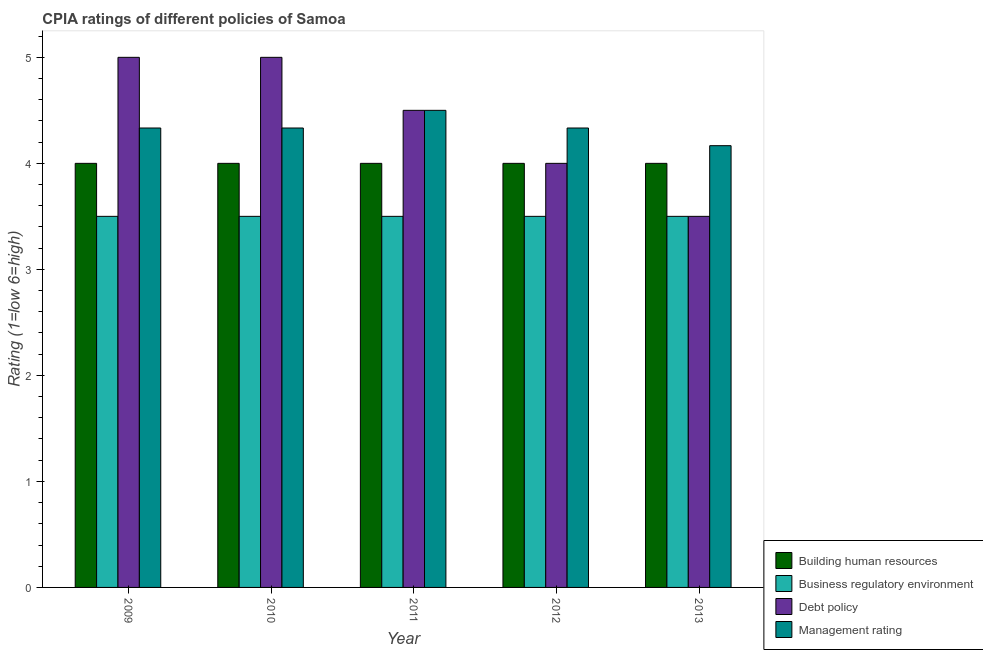How many different coloured bars are there?
Offer a very short reply. 4. Are the number of bars on each tick of the X-axis equal?
Provide a short and direct response. Yes. How many bars are there on the 4th tick from the left?
Your answer should be compact. 4. How many bars are there on the 5th tick from the right?
Provide a short and direct response. 4. What is the label of the 5th group of bars from the left?
Give a very brief answer. 2013. In how many cases, is the number of bars for a given year not equal to the number of legend labels?
Your answer should be very brief. 0. Across all years, what is the minimum cpia rating of business regulatory environment?
Keep it short and to the point. 3.5. What is the average cpia rating of building human resources per year?
Offer a very short reply. 4. In the year 2009, what is the difference between the cpia rating of building human resources and cpia rating of debt policy?
Ensure brevity in your answer.  0. What is the ratio of the cpia rating of debt policy in 2009 to that in 2012?
Provide a succinct answer. 1.25. Is the cpia rating of management in 2010 less than that in 2013?
Keep it short and to the point. No. Is the difference between the cpia rating of management in 2009 and 2013 greater than the difference between the cpia rating of business regulatory environment in 2009 and 2013?
Provide a short and direct response. No. What is the difference between the highest and the second highest cpia rating of management?
Your answer should be very brief. 0.17. What is the difference between the highest and the lowest cpia rating of debt policy?
Ensure brevity in your answer.  1.5. What does the 3rd bar from the left in 2012 represents?
Provide a short and direct response. Debt policy. What does the 4th bar from the right in 2011 represents?
Make the answer very short. Building human resources. Are all the bars in the graph horizontal?
Give a very brief answer. No. What is the difference between two consecutive major ticks on the Y-axis?
Give a very brief answer. 1. Does the graph contain any zero values?
Your answer should be very brief. No. Does the graph contain grids?
Make the answer very short. No. How are the legend labels stacked?
Provide a succinct answer. Vertical. What is the title of the graph?
Ensure brevity in your answer.  CPIA ratings of different policies of Samoa. Does "Korea" appear as one of the legend labels in the graph?
Offer a terse response. No. What is the label or title of the X-axis?
Make the answer very short. Year. What is the Rating (1=low 6=high) in Debt policy in 2009?
Provide a short and direct response. 5. What is the Rating (1=low 6=high) in Management rating in 2009?
Ensure brevity in your answer.  4.33. What is the Rating (1=low 6=high) in Building human resources in 2010?
Provide a succinct answer. 4. What is the Rating (1=low 6=high) of Management rating in 2010?
Provide a succinct answer. 4.33. What is the Rating (1=low 6=high) in Building human resources in 2011?
Your response must be concise. 4. What is the Rating (1=low 6=high) in Business regulatory environment in 2011?
Provide a succinct answer. 3.5. What is the Rating (1=low 6=high) in Debt policy in 2011?
Provide a succinct answer. 4.5. What is the Rating (1=low 6=high) in Business regulatory environment in 2012?
Your answer should be very brief. 3.5. What is the Rating (1=low 6=high) in Management rating in 2012?
Your answer should be compact. 4.33. What is the Rating (1=low 6=high) of Debt policy in 2013?
Offer a very short reply. 3.5. What is the Rating (1=low 6=high) in Management rating in 2013?
Offer a terse response. 4.17. Across all years, what is the maximum Rating (1=low 6=high) in Business regulatory environment?
Ensure brevity in your answer.  3.5. Across all years, what is the minimum Rating (1=low 6=high) in Debt policy?
Your answer should be very brief. 3.5. Across all years, what is the minimum Rating (1=low 6=high) in Management rating?
Offer a very short reply. 4.17. What is the total Rating (1=low 6=high) of Business regulatory environment in the graph?
Your answer should be very brief. 17.5. What is the total Rating (1=low 6=high) of Management rating in the graph?
Your answer should be very brief. 21.67. What is the difference between the Rating (1=low 6=high) of Debt policy in 2009 and that in 2010?
Your answer should be compact. 0. What is the difference between the Rating (1=low 6=high) of Management rating in 2009 and that in 2010?
Provide a succinct answer. 0. What is the difference between the Rating (1=low 6=high) in Business regulatory environment in 2009 and that in 2011?
Your response must be concise. 0. What is the difference between the Rating (1=low 6=high) in Debt policy in 2009 and that in 2011?
Make the answer very short. 0.5. What is the difference between the Rating (1=low 6=high) of Management rating in 2009 and that in 2011?
Keep it short and to the point. -0.17. What is the difference between the Rating (1=low 6=high) in Debt policy in 2009 and that in 2012?
Provide a short and direct response. 1. What is the difference between the Rating (1=low 6=high) in Management rating in 2009 and that in 2012?
Provide a succinct answer. 0. What is the difference between the Rating (1=low 6=high) of Building human resources in 2009 and that in 2013?
Ensure brevity in your answer.  0. What is the difference between the Rating (1=low 6=high) of Building human resources in 2010 and that in 2011?
Your response must be concise. 0. What is the difference between the Rating (1=low 6=high) in Business regulatory environment in 2010 and that in 2011?
Ensure brevity in your answer.  0. What is the difference between the Rating (1=low 6=high) in Management rating in 2010 and that in 2011?
Offer a terse response. -0.17. What is the difference between the Rating (1=low 6=high) in Business regulatory environment in 2010 and that in 2012?
Your response must be concise. 0. What is the difference between the Rating (1=low 6=high) in Debt policy in 2010 and that in 2012?
Provide a succinct answer. 1. What is the difference between the Rating (1=low 6=high) of Management rating in 2010 and that in 2012?
Your response must be concise. 0. What is the difference between the Rating (1=low 6=high) of Debt policy in 2010 and that in 2013?
Make the answer very short. 1.5. What is the difference between the Rating (1=low 6=high) of Debt policy in 2011 and that in 2012?
Your response must be concise. 0.5. What is the difference between the Rating (1=low 6=high) of Management rating in 2011 and that in 2012?
Provide a succinct answer. 0.17. What is the difference between the Rating (1=low 6=high) of Building human resources in 2011 and that in 2013?
Your response must be concise. 0. What is the difference between the Rating (1=low 6=high) of Debt policy in 2011 and that in 2013?
Provide a short and direct response. 1. What is the difference between the Rating (1=low 6=high) in Building human resources in 2012 and that in 2013?
Offer a terse response. 0. What is the difference between the Rating (1=low 6=high) of Business regulatory environment in 2012 and that in 2013?
Ensure brevity in your answer.  0. What is the difference between the Rating (1=low 6=high) of Debt policy in 2012 and that in 2013?
Your answer should be very brief. 0.5. What is the difference between the Rating (1=low 6=high) in Building human resources in 2009 and the Rating (1=low 6=high) in Debt policy in 2010?
Your answer should be very brief. -1. What is the difference between the Rating (1=low 6=high) of Building human resources in 2009 and the Rating (1=low 6=high) of Management rating in 2010?
Provide a short and direct response. -0.33. What is the difference between the Rating (1=low 6=high) of Business regulatory environment in 2009 and the Rating (1=low 6=high) of Debt policy in 2010?
Provide a succinct answer. -1.5. What is the difference between the Rating (1=low 6=high) in Business regulatory environment in 2009 and the Rating (1=low 6=high) in Management rating in 2010?
Give a very brief answer. -0.83. What is the difference between the Rating (1=low 6=high) in Debt policy in 2009 and the Rating (1=low 6=high) in Management rating in 2010?
Ensure brevity in your answer.  0.67. What is the difference between the Rating (1=low 6=high) of Building human resources in 2009 and the Rating (1=low 6=high) of Business regulatory environment in 2011?
Make the answer very short. 0.5. What is the difference between the Rating (1=low 6=high) in Building human resources in 2009 and the Rating (1=low 6=high) in Debt policy in 2011?
Offer a terse response. -0.5. What is the difference between the Rating (1=low 6=high) in Business regulatory environment in 2009 and the Rating (1=low 6=high) in Debt policy in 2011?
Your response must be concise. -1. What is the difference between the Rating (1=low 6=high) of Debt policy in 2009 and the Rating (1=low 6=high) of Management rating in 2011?
Make the answer very short. 0.5. What is the difference between the Rating (1=low 6=high) of Building human resources in 2009 and the Rating (1=low 6=high) of Debt policy in 2012?
Your answer should be compact. 0. What is the difference between the Rating (1=low 6=high) of Business regulatory environment in 2009 and the Rating (1=low 6=high) of Debt policy in 2012?
Ensure brevity in your answer.  -0.5. What is the difference between the Rating (1=low 6=high) of Business regulatory environment in 2009 and the Rating (1=low 6=high) of Management rating in 2012?
Offer a very short reply. -0.83. What is the difference between the Rating (1=low 6=high) in Debt policy in 2009 and the Rating (1=low 6=high) in Management rating in 2012?
Give a very brief answer. 0.67. What is the difference between the Rating (1=low 6=high) of Building human resources in 2009 and the Rating (1=low 6=high) of Business regulatory environment in 2013?
Provide a succinct answer. 0.5. What is the difference between the Rating (1=low 6=high) of Building human resources in 2009 and the Rating (1=low 6=high) of Debt policy in 2013?
Give a very brief answer. 0.5. What is the difference between the Rating (1=low 6=high) of Building human resources in 2009 and the Rating (1=low 6=high) of Management rating in 2013?
Keep it short and to the point. -0.17. What is the difference between the Rating (1=low 6=high) of Debt policy in 2009 and the Rating (1=low 6=high) of Management rating in 2013?
Offer a terse response. 0.83. What is the difference between the Rating (1=low 6=high) of Building human resources in 2010 and the Rating (1=low 6=high) of Business regulatory environment in 2011?
Ensure brevity in your answer.  0.5. What is the difference between the Rating (1=low 6=high) in Building human resources in 2010 and the Rating (1=low 6=high) in Debt policy in 2011?
Provide a short and direct response. -0.5. What is the difference between the Rating (1=low 6=high) of Building human resources in 2010 and the Rating (1=low 6=high) of Management rating in 2011?
Your response must be concise. -0.5. What is the difference between the Rating (1=low 6=high) in Business regulatory environment in 2010 and the Rating (1=low 6=high) in Debt policy in 2011?
Offer a very short reply. -1. What is the difference between the Rating (1=low 6=high) of Business regulatory environment in 2010 and the Rating (1=low 6=high) of Management rating in 2011?
Your response must be concise. -1. What is the difference between the Rating (1=low 6=high) in Business regulatory environment in 2010 and the Rating (1=low 6=high) in Debt policy in 2012?
Make the answer very short. -0.5. What is the difference between the Rating (1=low 6=high) in Debt policy in 2010 and the Rating (1=low 6=high) in Management rating in 2012?
Offer a very short reply. 0.67. What is the difference between the Rating (1=low 6=high) of Building human resources in 2010 and the Rating (1=low 6=high) of Business regulatory environment in 2013?
Keep it short and to the point. 0.5. What is the difference between the Rating (1=low 6=high) of Building human resources in 2010 and the Rating (1=low 6=high) of Management rating in 2013?
Provide a succinct answer. -0.17. What is the difference between the Rating (1=low 6=high) in Building human resources in 2011 and the Rating (1=low 6=high) in Debt policy in 2012?
Give a very brief answer. 0. What is the difference between the Rating (1=low 6=high) of Business regulatory environment in 2011 and the Rating (1=low 6=high) of Debt policy in 2012?
Give a very brief answer. -0.5. What is the difference between the Rating (1=low 6=high) of Business regulatory environment in 2011 and the Rating (1=low 6=high) of Management rating in 2012?
Ensure brevity in your answer.  -0.83. What is the difference between the Rating (1=low 6=high) in Building human resources in 2011 and the Rating (1=low 6=high) in Debt policy in 2013?
Your answer should be compact. 0.5. What is the difference between the Rating (1=low 6=high) in Building human resources in 2011 and the Rating (1=low 6=high) in Management rating in 2013?
Provide a short and direct response. -0.17. What is the difference between the Rating (1=low 6=high) of Business regulatory environment in 2011 and the Rating (1=low 6=high) of Debt policy in 2013?
Provide a short and direct response. 0. What is the difference between the Rating (1=low 6=high) of Building human resources in 2012 and the Rating (1=low 6=high) of Business regulatory environment in 2013?
Keep it short and to the point. 0.5. What is the difference between the Rating (1=low 6=high) in Building human resources in 2012 and the Rating (1=low 6=high) in Management rating in 2013?
Your answer should be compact. -0.17. What is the difference between the Rating (1=low 6=high) in Business regulatory environment in 2012 and the Rating (1=low 6=high) in Debt policy in 2013?
Make the answer very short. 0. What is the average Rating (1=low 6=high) in Debt policy per year?
Offer a very short reply. 4.4. What is the average Rating (1=low 6=high) in Management rating per year?
Your response must be concise. 4.33. In the year 2010, what is the difference between the Rating (1=low 6=high) in Building human resources and Rating (1=low 6=high) in Management rating?
Offer a very short reply. -0.33. In the year 2010, what is the difference between the Rating (1=low 6=high) of Business regulatory environment and Rating (1=low 6=high) of Management rating?
Provide a short and direct response. -0.83. In the year 2011, what is the difference between the Rating (1=low 6=high) in Building human resources and Rating (1=low 6=high) in Business regulatory environment?
Your answer should be compact. 0.5. In the year 2011, what is the difference between the Rating (1=low 6=high) of Building human resources and Rating (1=low 6=high) of Debt policy?
Offer a very short reply. -0.5. In the year 2011, what is the difference between the Rating (1=low 6=high) in Building human resources and Rating (1=low 6=high) in Management rating?
Provide a succinct answer. -0.5. In the year 2011, what is the difference between the Rating (1=low 6=high) in Business regulatory environment and Rating (1=low 6=high) in Management rating?
Make the answer very short. -1. In the year 2012, what is the difference between the Rating (1=low 6=high) of Building human resources and Rating (1=low 6=high) of Debt policy?
Provide a succinct answer. 0. In the year 2012, what is the difference between the Rating (1=low 6=high) in Building human resources and Rating (1=low 6=high) in Management rating?
Ensure brevity in your answer.  -0.33. In the year 2012, what is the difference between the Rating (1=low 6=high) in Business regulatory environment and Rating (1=low 6=high) in Debt policy?
Offer a very short reply. -0.5. In the year 2012, what is the difference between the Rating (1=low 6=high) in Business regulatory environment and Rating (1=low 6=high) in Management rating?
Offer a very short reply. -0.83. In the year 2013, what is the difference between the Rating (1=low 6=high) in Building human resources and Rating (1=low 6=high) in Debt policy?
Make the answer very short. 0.5. In the year 2013, what is the difference between the Rating (1=low 6=high) in Building human resources and Rating (1=low 6=high) in Management rating?
Ensure brevity in your answer.  -0.17. In the year 2013, what is the difference between the Rating (1=low 6=high) in Business regulatory environment and Rating (1=low 6=high) in Debt policy?
Provide a succinct answer. 0. What is the ratio of the Rating (1=low 6=high) in Building human resources in 2009 to that in 2011?
Ensure brevity in your answer.  1. What is the ratio of the Rating (1=low 6=high) of Business regulatory environment in 2009 to that in 2011?
Offer a terse response. 1. What is the ratio of the Rating (1=low 6=high) in Debt policy in 2009 to that in 2011?
Give a very brief answer. 1.11. What is the ratio of the Rating (1=low 6=high) in Building human resources in 2009 to that in 2012?
Give a very brief answer. 1. What is the ratio of the Rating (1=low 6=high) of Business regulatory environment in 2009 to that in 2012?
Your answer should be compact. 1. What is the ratio of the Rating (1=low 6=high) in Building human resources in 2009 to that in 2013?
Your response must be concise. 1. What is the ratio of the Rating (1=low 6=high) of Debt policy in 2009 to that in 2013?
Offer a very short reply. 1.43. What is the ratio of the Rating (1=low 6=high) in Management rating in 2010 to that in 2011?
Keep it short and to the point. 0.96. What is the ratio of the Rating (1=low 6=high) in Building human resources in 2010 to that in 2012?
Ensure brevity in your answer.  1. What is the ratio of the Rating (1=low 6=high) in Business regulatory environment in 2010 to that in 2012?
Your answer should be compact. 1. What is the ratio of the Rating (1=low 6=high) of Management rating in 2010 to that in 2012?
Provide a succinct answer. 1. What is the ratio of the Rating (1=low 6=high) of Debt policy in 2010 to that in 2013?
Your answer should be compact. 1.43. What is the ratio of the Rating (1=low 6=high) of Management rating in 2010 to that in 2013?
Keep it short and to the point. 1.04. What is the ratio of the Rating (1=low 6=high) in Management rating in 2011 to that in 2012?
Your response must be concise. 1.04. What is the ratio of the Rating (1=low 6=high) of Business regulatory environment in 2011 to that in 2013?
Keep it short and to the point. 1. What is the ratio of the Rating (1=low 6=high) in Management rating in 2011 to that in 2013?
Your answer should be very brief. 1.08. What is the ratio of the Rating (1=low 6=high) of Business regulatory environment in 2012 to that in 2013?
Offer a very short reply. 1. What is the ratio of the Rating (1=low 6=high) of Debt policy in 2012 to that in 2013?
Your answer should be compact. 1.14. What is the difference between the highest and the second highest Rating (1=low 6=high) in Building human resources?
Your response must be concise. 0. What is the difference between the highest and the second highest Rating (1=low 6=high) in Business regulatory environment?
Offer a terse response. 0. What is the difference between the highest and the second highest Rating (1=low 6=high) in Debt policy?
Provide a short and direct response. 0. What is the difference between the highest and the second highest Rating (1=low 6=high) of Management rating?
Provide a short and direct response. 0.17. What is the difference between the highest and the lowest Rating (1=low 6=high) in Building human resources?
Offer a terse response. 0. What is the difference between the highest and the lowest Rating (1=low 6=high) in Management rating?
Ensure brevity in your answer.  0.33. 